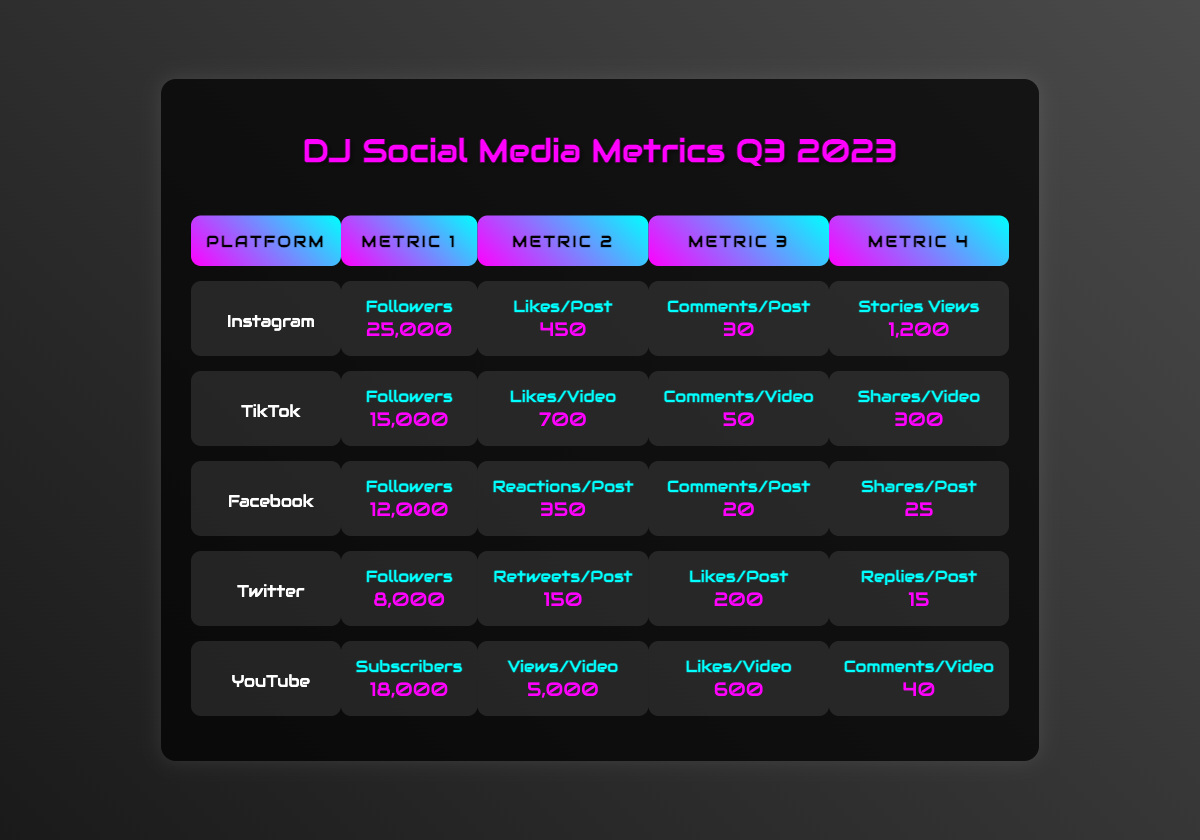What is the total number of followers across all platforms? The followers on each platform are: Instagram (25,000), TikTok (15,000), Facebook (12,000), Twitter (8,000), and YouTube (18,000). Adding these together: 25,000 + 15,000 + 12,000 + 8,000 + 18,000 = 78,000.
Answer: 78,000 Which platform has the highest likes per post or video? Instagram has 450 likes per post, TikTok has 700 likes per video, Facebook has 350 reactions per post, Twitter has 200 likes per post, and YouTube has 600 likes per video. The highest is TikTok with 700 likes per video.
Answer: TikTok What is the difference in followers between Instagram and Twitter? Instagram has 25,000 followers, and Twitter has 8,000 followers. The difference is calculated as 25,000 - 8,000 = 17,000.
Answer: 17,000 Does Facebook have more comments per post than Twitter? Facebook has an average of 20 comments per post, and Twitter has an average of 15 replies per post. Since 20 is greater than 15, the statement is true.
Answer: Yes What is the average likes per post or video across all platforms? The total likes are: Instagram (450), TikTok (700), Facebook (350), Twitter (200), and YouTube (600). The sum is 450 + 700 + 350 + 200 + 600 = 2,300. There are 5 platforms, so the average is 2,300 / 5 = 460.
Answer: 460 If you combine the comments per post for Instagram and Facebook, what is the total? Instagram has 30 comments per post, and Facebook has 20 comments per post. Adding these together gives 30 + 20 = 50.
Answer: 50 Which platform has the least number of followers? The follower counts are: Instagram (25,000), TikTok (15,000), Facebook (12,000), Twitter (8,000), and YouTube (18,000). The least is Twitter with 8,000 followers.
Answer: Twitter What percentage of total followers does TikTok represent? The total number of followers is 78,000, and TikTok has 15,000 followers. The percentage is (15,000 / 78,000) * 100 = 19.23%.
Answer: 19.23% Which platform has the highest engagement in terms of likes or reactions per post? The likes/reactions per post are: Instagram (450), TikTok (700), Facebook (350), Twitter (200), and YouTube (600). TikTok has the highest engagement with 700 likes per video.
Answer: TikTok If you were to average the views per video for just YouTube, what would that be? YouTube has 5,000 views per video. Since there is only one data point, the average is also 5,000.
Answer: 5,000 